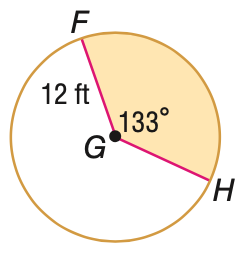Answer the mathemtical geometry problem and directly provide the correct option letter.
Question: Find the area of the shaded sector. Round to the nearest tenth, if necessary.
Choices: A: 47.5 B: 167.1 C: 285.3 D: 452.4 B 